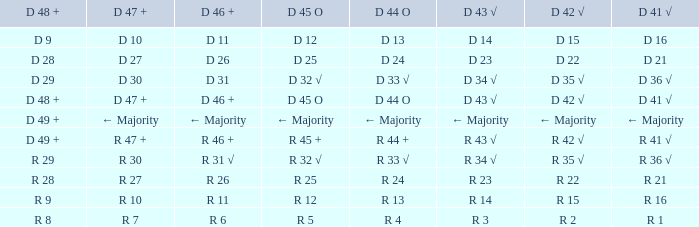What is the value of D 45 O when the value of D 44 O is ← majority? ← Majority. 